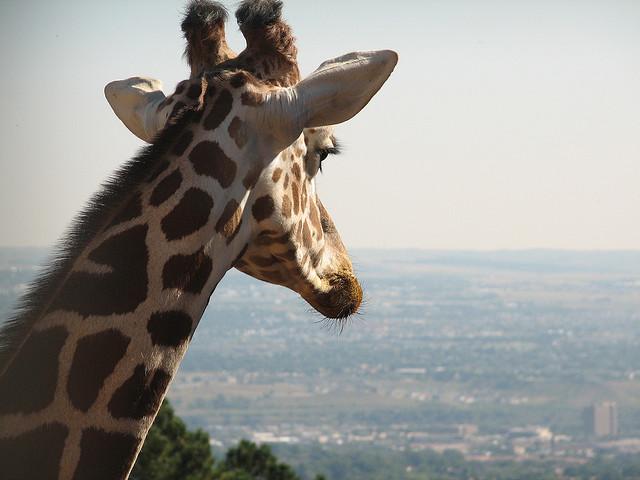What is the animal looking at?
Answer briefly. City. What is green in the picture?
Answer briefly. Trees. Is this animal indigenous to the United States?
Concise answer only. No. 